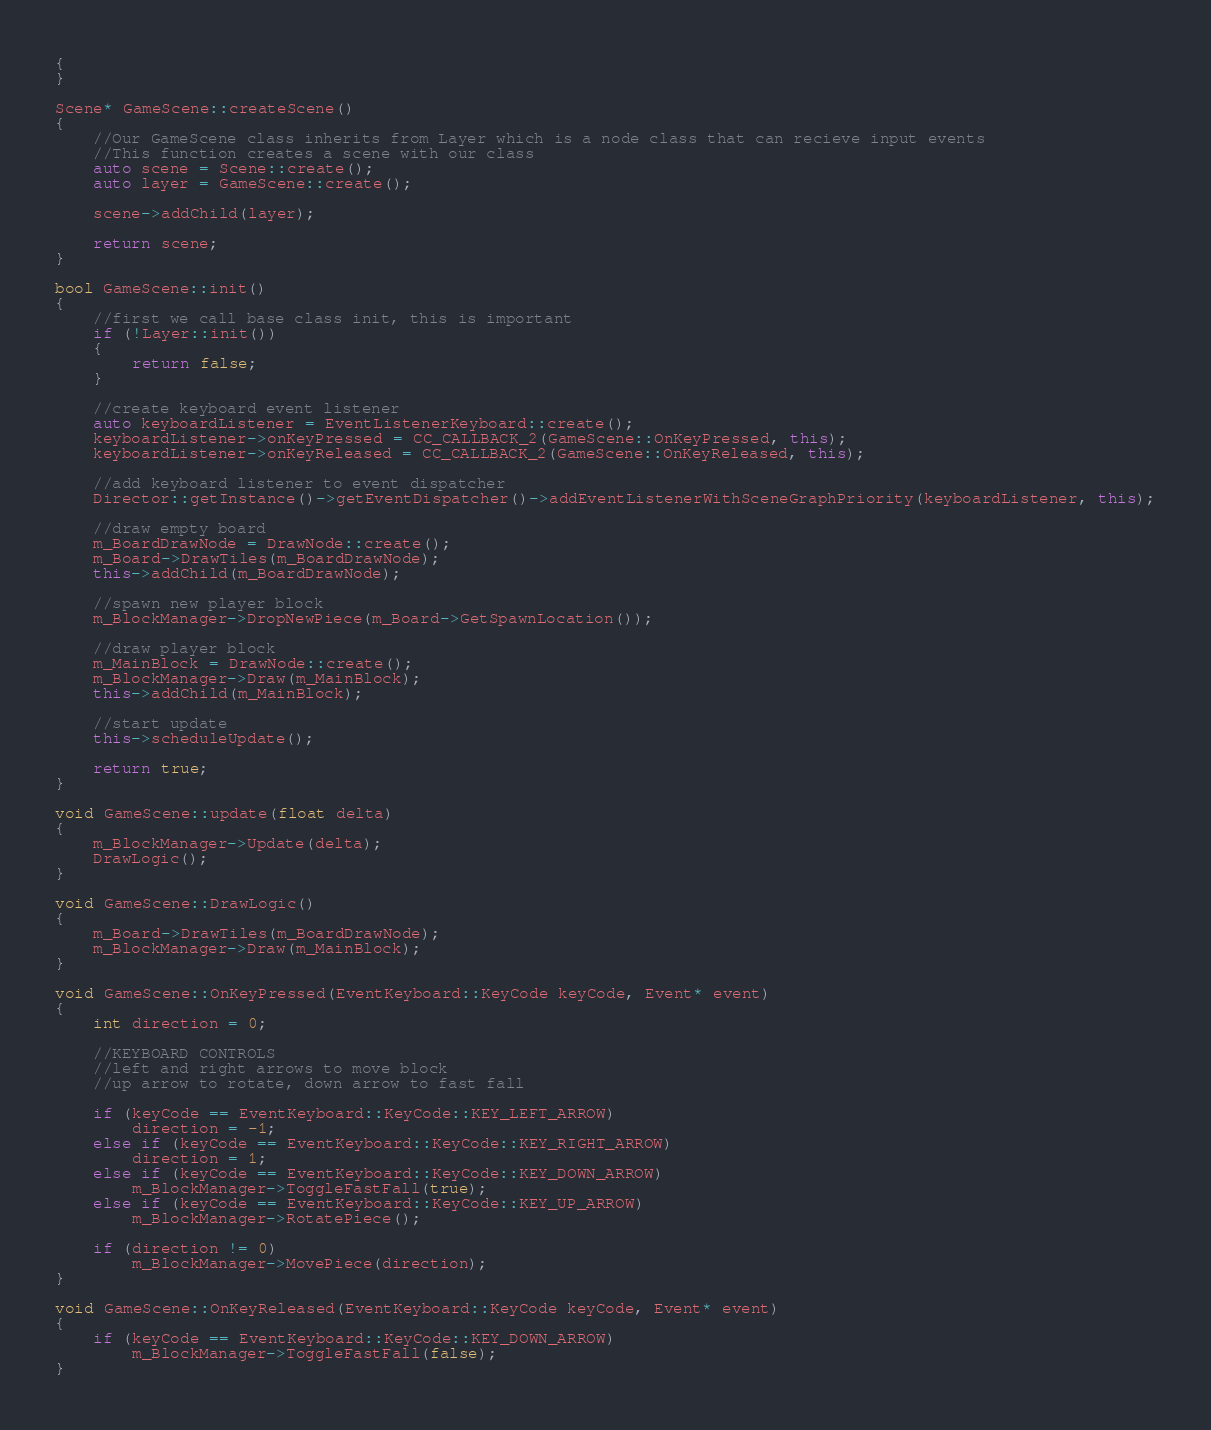<code> <loc_0><loc_0><loc_500><loc_500><_C++_>{
}

Scene* GameScene::createScene()
{
	//Our GameScene class inherits from Layer which is a node class that can recieve input events
	//This function creates a scene with our class
	auto scene = Scene::create();
	auto layer = GameScene::create();

	scene->addChild(layer);

	return scene;
}

bool GameScene::init()
{
	//first we call base class init, this is important
	if (!Layer::init())
	{
		return false;
	}

	//create keyboard event listener
	auto keyboardListener = EventListenerKeyboard::create();
	keyboardListener->onKeyPressed = CC_CALLBACK_2(GameScene::OnKeyPressed, this);
	keyboardListener->onKeyReleased = CC_CALLBACK_2(GameScene::OnKeyReleased, this);

	//add keyboard listener to event dispatcher
	Director::getInstance()->getEventDispatcher()->addEventListenerWithSceneGraphPriority(keyboardListener, this);

	//draw empty board
	m_BoardDrawNode = DrawNode::create();
	m_Board->DrawTiles(m_BoardDrawNode);
	this->addChild(m_BoardDrawNode);
	
	//spawn new player block
	m_BlockManager->DropNewPiece(m_Board->GetSpawnLocation());

	//draw player block
	m_MainBlock = DrawNode::create();
	m_BlockManager->Draw(m_MainBlock);
	this->addChild(m_MainBlock);

	//start update
	this->scheduleUpdate();

	return true;
}

void GameScene::update(float delta)
{
	m_BlockManager->Update(delta);
	DrawLogic();
}

void GameScene::DrawLogic()
{
	m_Board->DrawTiles(m_BoardDrawNode);
	m_BlockManager->Draw(m_MainBlock);
}

void GameScene::OnKeyPressed(EventKeyboard::KeyCode keyCode, Event* event)
{
	int direction = 0;

	//KEYBOARD CONTROLS
	//left and right arrows to move block
	//up arrow to rotate, down arrow to fast fall

	if (keyCode == EventKeyboard::KeyCode::KEY_LEFT_ARROW)
		direction = -1;
	else if (keyCode == EventKeyboard::KeyCode::KEY_RIGHT_ARROW)
		direction = 1;
	else if (keyCode == EventKeyboard::KeyCode::KEY_DOWN_ARROW)
		m_BlockManager->ToggleFastFall(true);
	else if (keyCode == EventKeyboard::KeyCode::KEY_UP_ARROW)
		m_BlockManager->RotatePiece();
		
	if (direction != 0)
		m_BlockManager->MovePiece(direction);
}

void GameScene::OnKeyReleased(EventKeyboard::KeyCode keyCode, Event* event)
{
	if (keyCode == EventKeyboard::KeyCode::KEY_DOWN_ARROW)
		m_BlockManager->ToggleFastFall(false);
}
</code> 